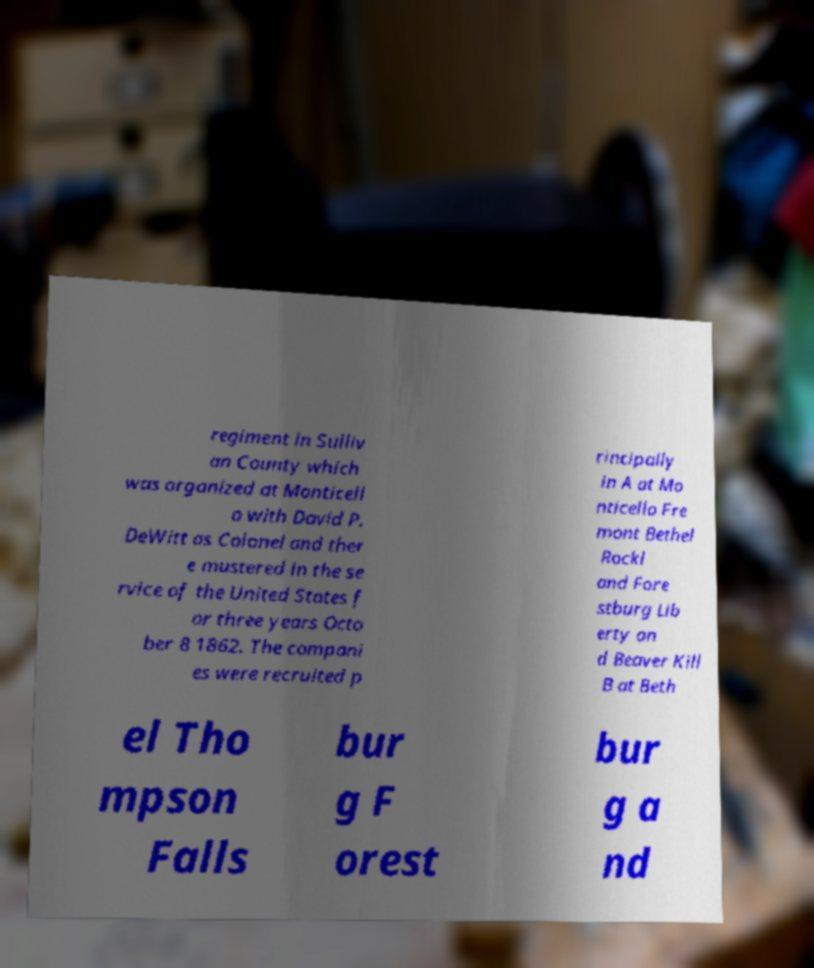Could you extract and type out the text from this image? regiment in Sulliv an County which was organized at Monticell o with David P. DeWitt as Colonel and ther e mustered in the se rvice of the United States f or three years Octo ber 8 1862. The compani es were recruited p rincipally in A at Mo nticello Fre mont Bethel Rockl and Fore stburg Lib erty an d Beaver Kill B at Beth el Tho mpson Falls bur g F orest bur g a nd 